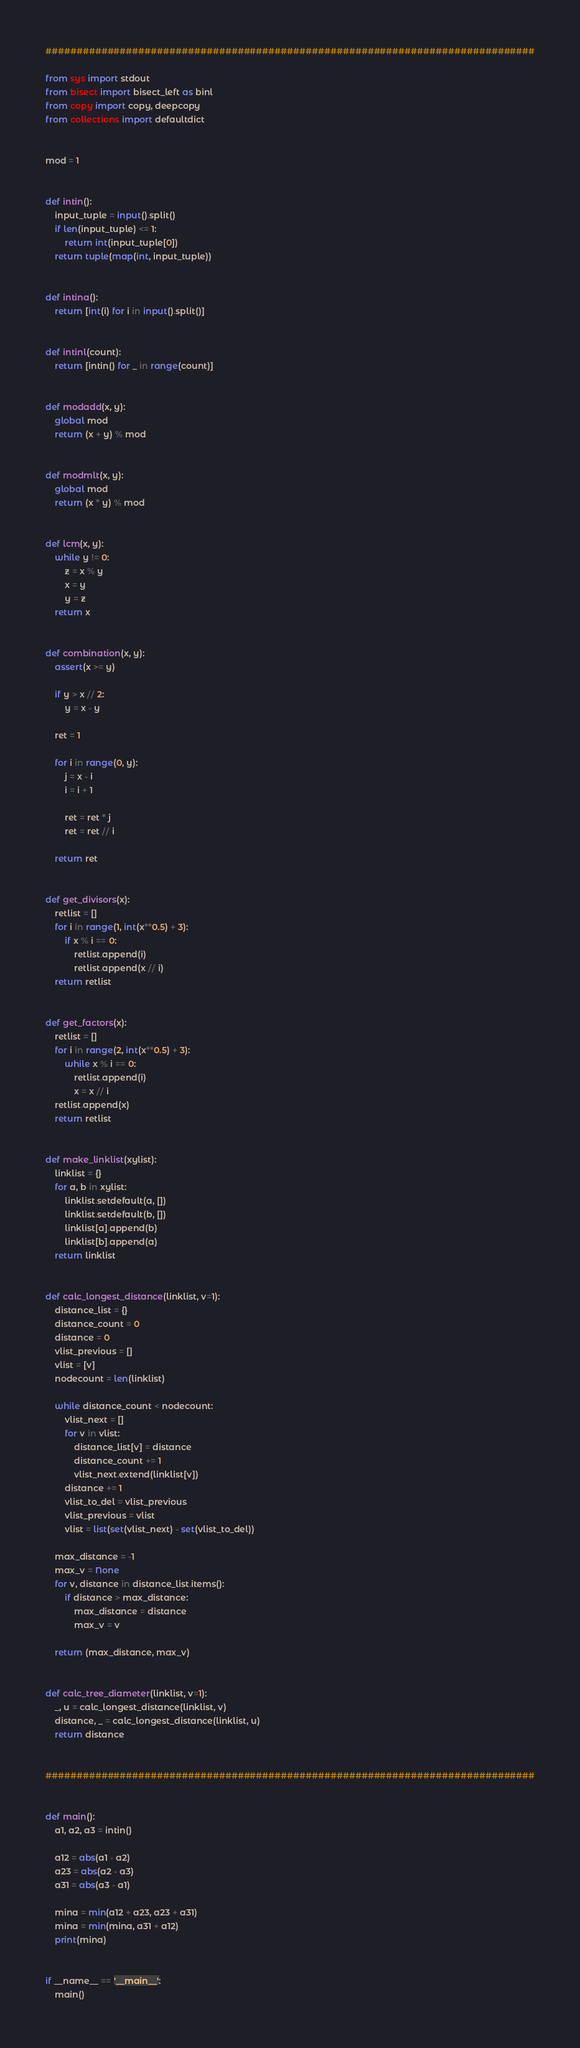<code> <loc_0><loc_0><loc_500><loc_500><_Python_>###############################################################################

from sys import stdout
from bisect import bisect_left as binl
from copy import copy, deepcopy
from collections import defaultdict


mod = 1


def intin():
    input_tuple = input().split()
    if len(input_tuple) <= 1:
        return int(input_tuple[0])
    return tuple(map(int, input_tuple))


def intina():
    return [int(i) for i in input().split()]


def intinl(count):
    return [intin() for _ in range(count)]


def modadd(x, y):
    global mod
    return (x + y) % mod


def modmlt(x, y):
    global mod
    return (x * y) % mod


def lcm(x, y):
    while y != 0:
        z = x % y
        x = y
        y = z
    return x


def combination(x, y):
    assert(x >= y)

    if y > x // 2:
        y = x - y

    ret = 1

    for i in range(0, y):
        j = x - i
        i = i + 1

        ret = ret * j
        ret = ret // i

    return ret


def get_divisors(x):
    retlist = []
    for i in range(1, int(x**0.5) + 3):
        if x % i == 0:
            retlist.append(i)
            retlist.append(x // i)
    return retlist


def get_factors(x):
    retlist = []
    for i in range(2, int(x**0.5) + 3):
        while x % i == 0:
            retlist.append(i)
            x = x // i
    retlist.append(x)
    return retlist


def make_linklist(xylist):
    linklist = {}
    for a, b in xylist:
        linklist.setdefault(a, [])
        linklist.setdefault(b, [])
        linklist[a].append(b)
        linklist[b].append(a)
    return linklist


def calc_longest_distance(linklist, v=1):
    distance_list = {}
    distance_count = 0
    distance = 0
    vlist_previous = []
    vlist = [v]
    nodecount = len(linklist)

    while distance_count < nodecount:
        vlist_next = []
        for v in vlist:
            distance_list[v] = distance
            distance_count += 1
            vlist_next.extend(linklist[v])
        distance += 1
        vlist_to_del = vlist_previous
        vlist_previous = vlist
        vlist = list(set(vlist_next) - set(vlist_to_del))

    max_distance = -1
    max_v = None
    for v, distance in distance_list.items():
        if distance > max_distance:
            max_distance = distance
            max_v = v

    return (max_distance, max_v)


def calc_tree_diameter(linklist, v=1):
    _, u = calc_longest_distance(linklist, v)
    distance, _ = calc_longest_distance(linklist, u)
    return distance


###############################################################################


def main():
    a1, a2, a3 = intin()

    a12 = abs(a1 - a2)
    a23 = abs(a2 - a3)
    a31 = abs(a3 - a1)

    mina = min(a12 + a23, a23 + a31)
    mina = min(mina, a31 + a12)
    print(mina)


if __name__ == '__main__':
    main()
</code> 